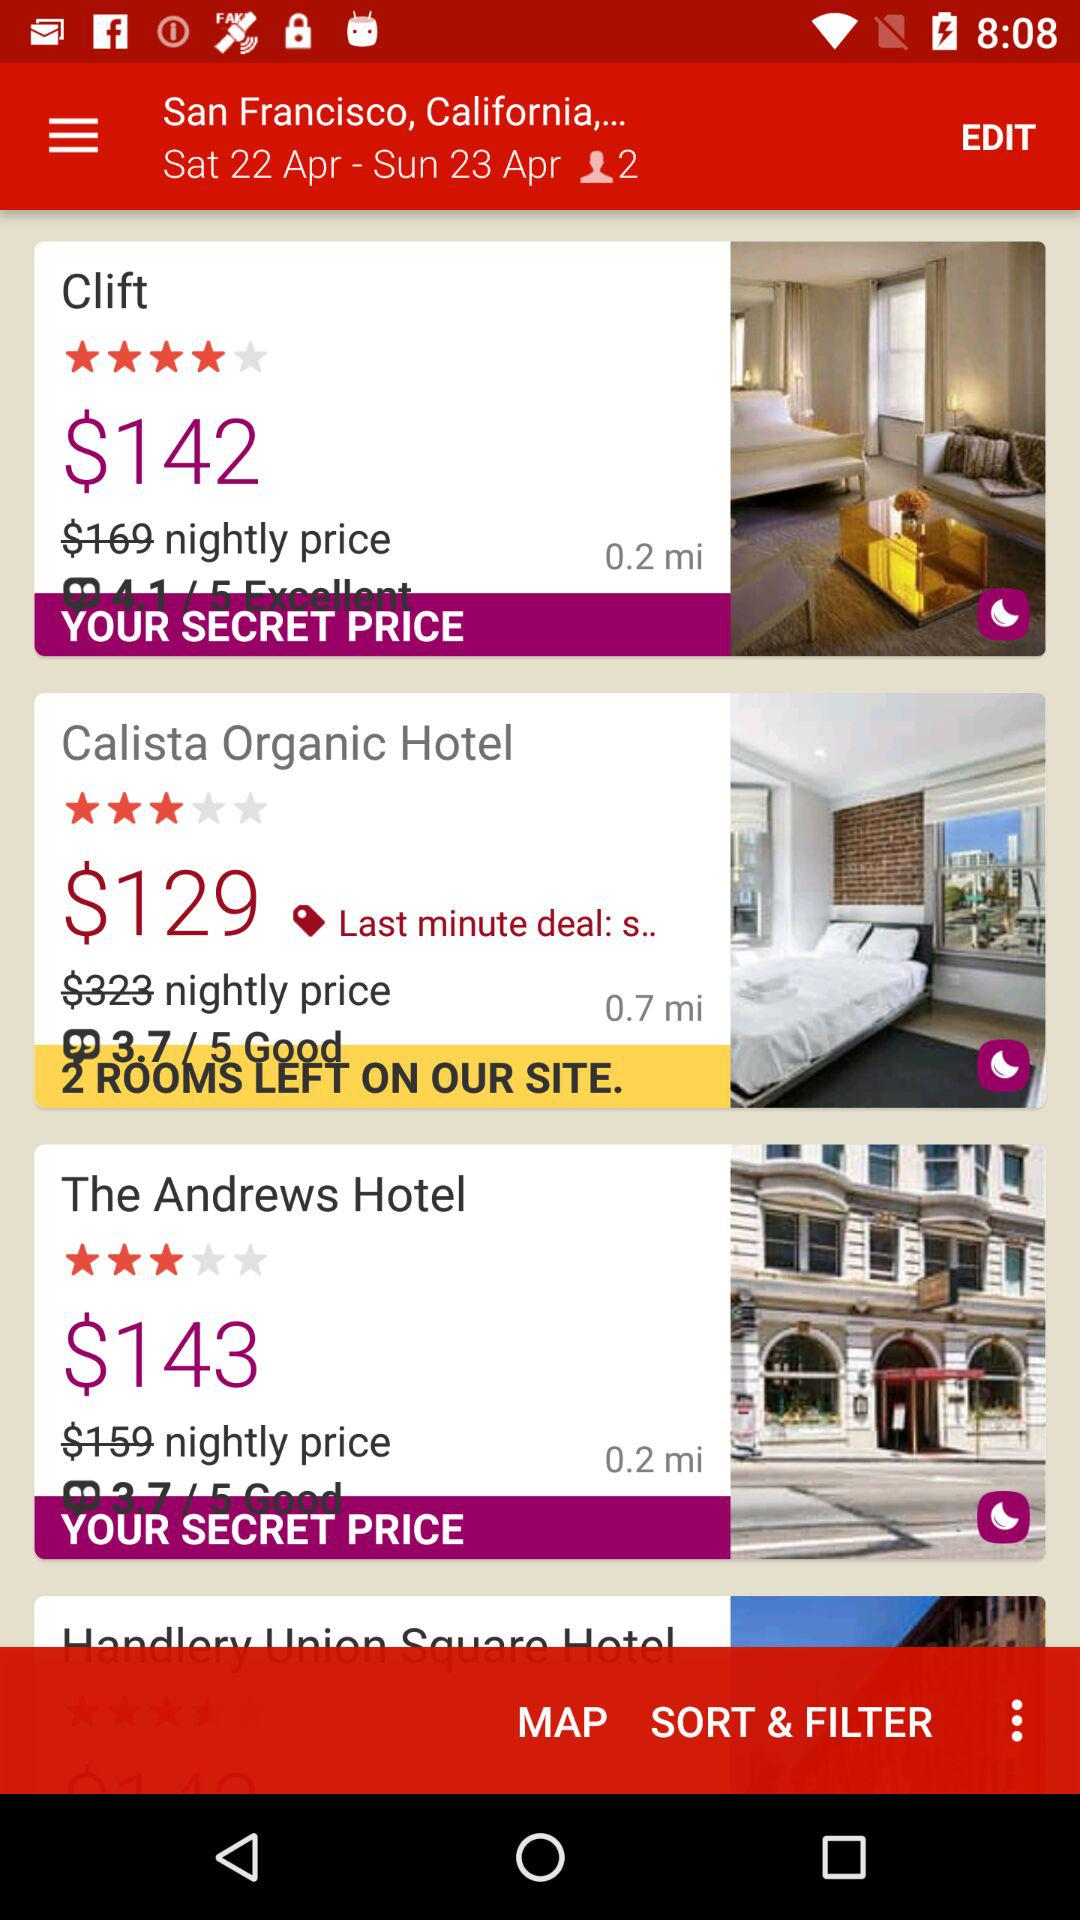How many hotels have a price of less than $150?
Answer the question using a single word or phrase. 3 